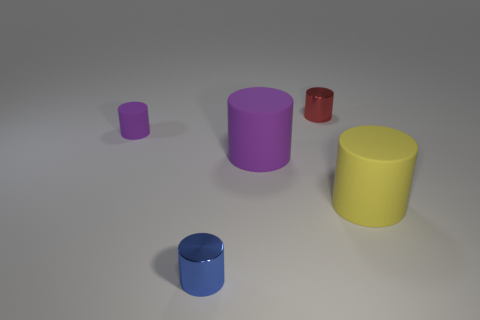Subtract all red cylinders. How many cylinders are left? 4 Subtract all yellow cylinders. How many cylinders are left? 4 Subtract 4 cylinders. How many cylinders are left? 1 Subtract all purple cylinders. Subtract all gray spheres. How many cylinders are left? 3 Subtract all purple cubes. How many purple cylinders are left? 2 Subtract all large metallic objects. Subtract all tiny shiny cylinders. How many objects are left? 3 Add 2 blue objects. How many blue objects are left? 3 Add 4 tiny cylinders. How many tiny cylinders exist? 7 Add 1 large yellow things. How many objects exist? 6 Subtract 0 red spheres. How many objects are left? 5 